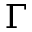<formula> <loc_0><loc_0><loc_500><loc_500>\Gamma</formula> 